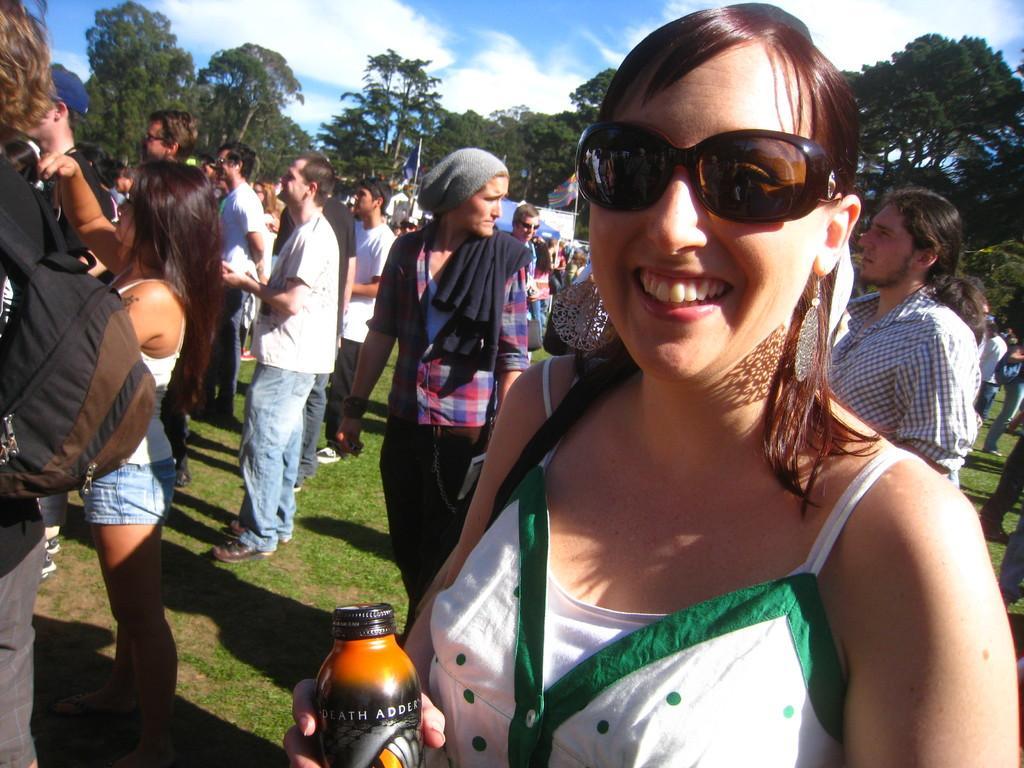How would you summarize this image in a sentence or two? In the middle of the image few people are standing. Top right side of the image there are some trees. Top left side of the image there are some trees. At the top of the image there are some clouds and sky. 